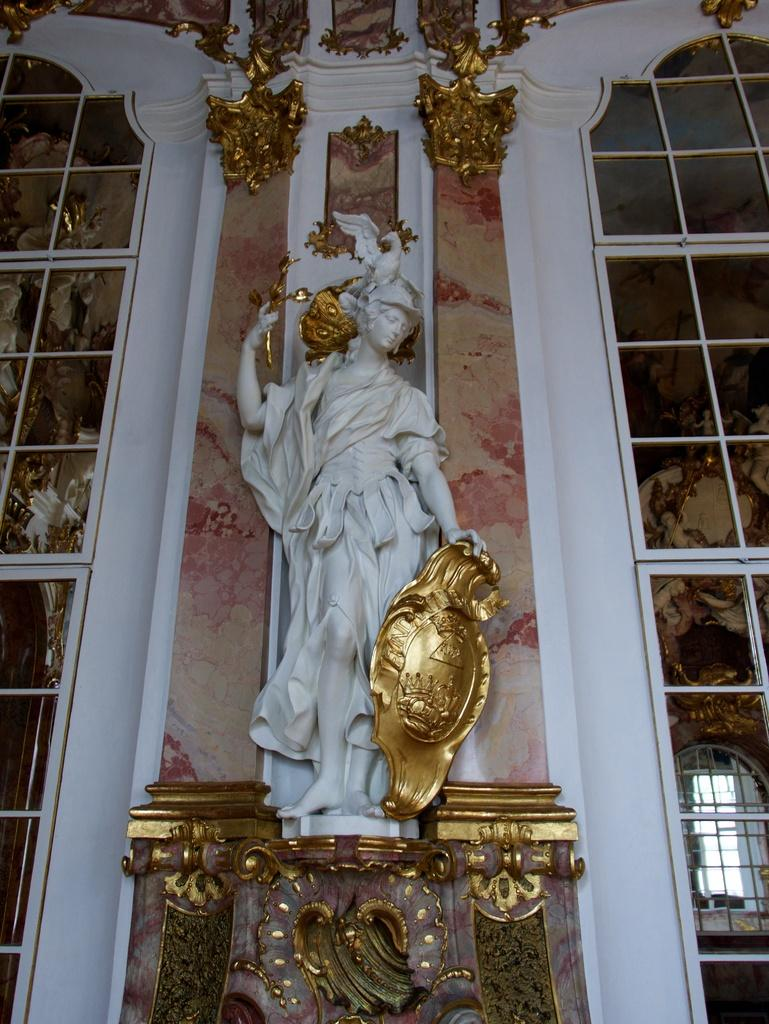What is the main structure visible in the image? There is a building in the image. Is there any additional feature attached to the building? Yes, there is a sculpture attached to the building. How many children are playing with the record in the image? There are no children or records present in the image. 